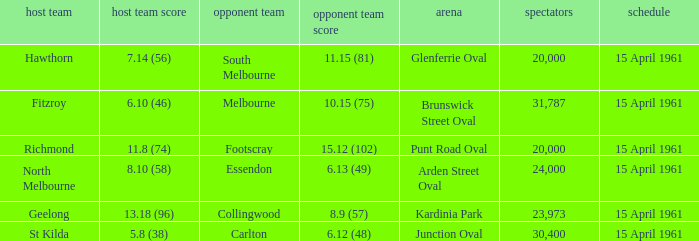What is the average crowd size when Collingwood is the away team? 23973.0. 